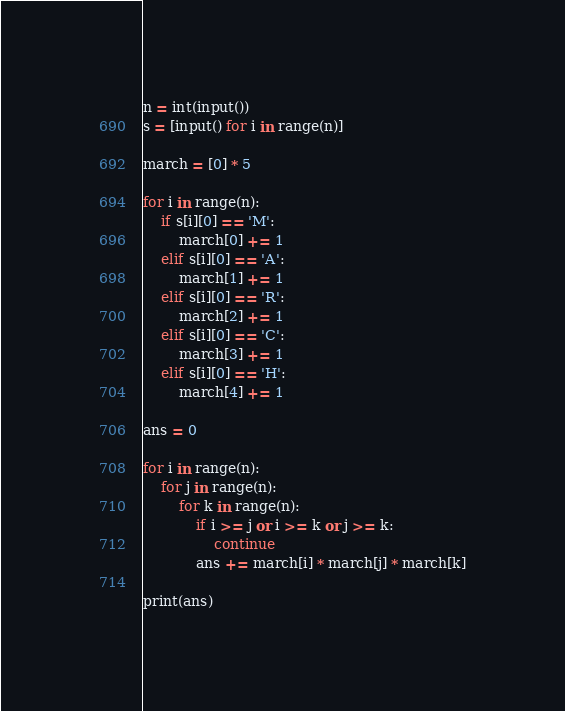Convert code to text. <code><loc_0><loc_0><loc_500><loc_500><_Python_>n = int(input())
s = [input() for i in range(n)]

march = [0] * 5

for i in range(n):
    if s[i][0] == 'M':
        march[0] += 1
    elif s[i][0] == 'A':
        march[1] += 1
    elif s[i][0] == 'R':
        march[2] += 1
    elif s[i][0] == 'C':
        march[3] += 1
    elif s[i][0] == 'H':
        march[4] += 1
        
ans = 0
        
for i in range(n):
    for j in range(n):
        for k in range(n):
            if i >= j or i >= k or j >= k:
                continue
            ans += march[i] * march[j] * march[k]
            
print(ans)</code> 